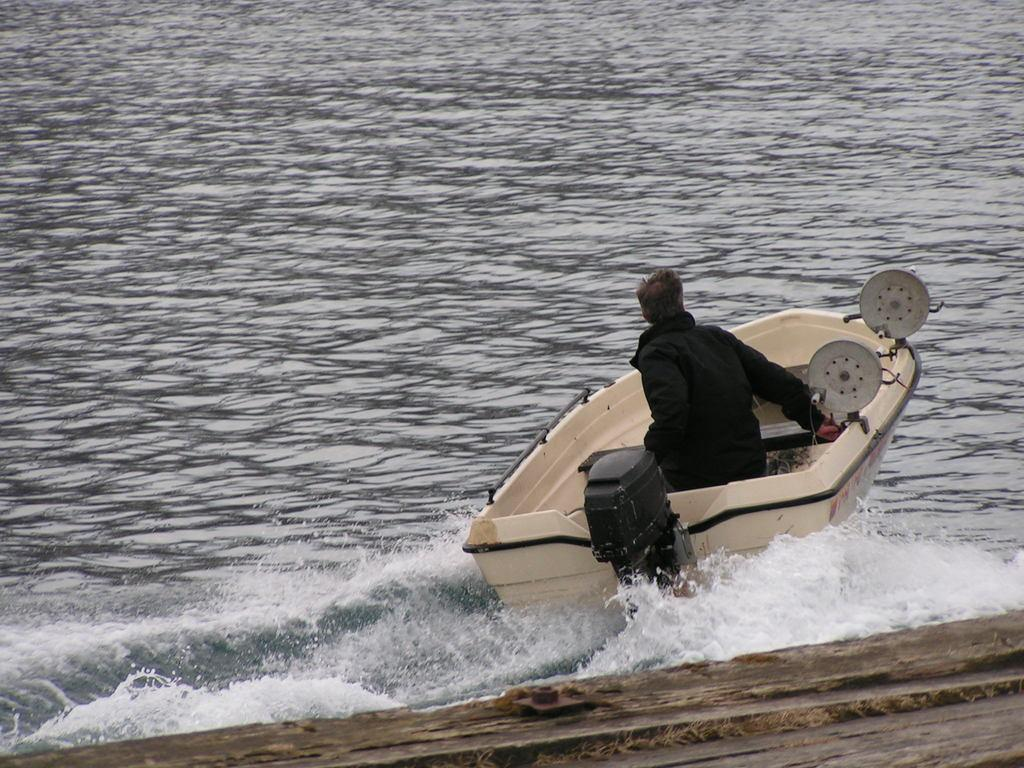What is at the bottom of the image? There is water at the bottom of the image. What is the person in the image doing? A person is riding a boat above the water. What type of quince is being used as a paddle for the boat in the image? There is no quince present in the image, and the person is not using a quince as a paddle for the boat. What kind of argument is taking place between the person and the water in the image? There is no argument present in the image; it simply shows a person riding a boat above the water. 